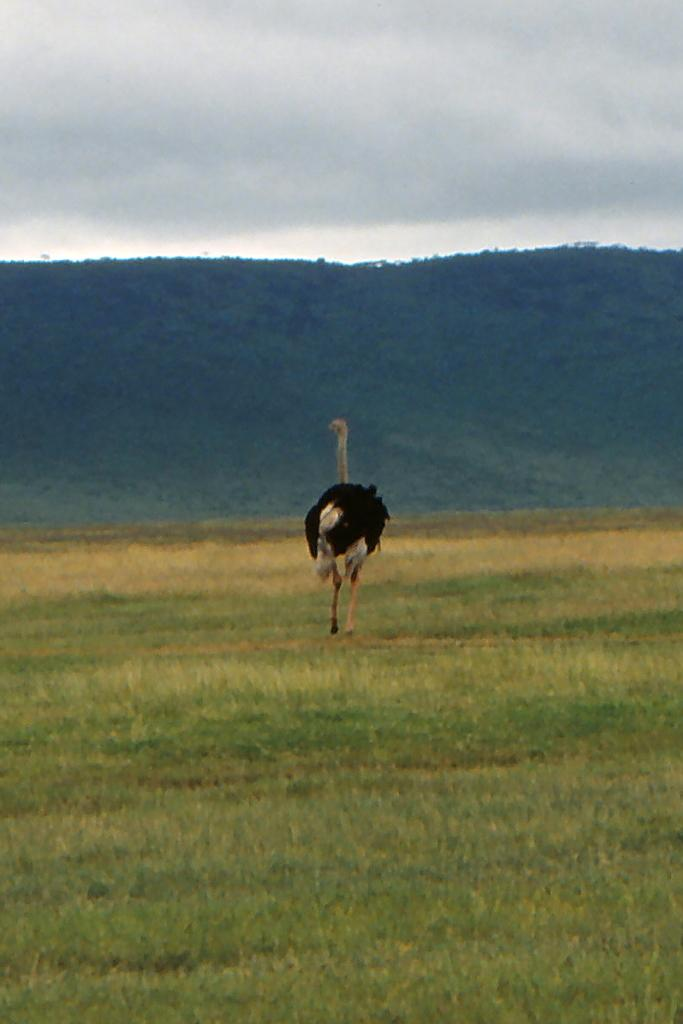What type of animal is in the image? There is an ostrich bird in the image. Where is the ostrich bird located? The ostrich bird is on the grass. What can be seen in the background of the image? There is a hill and clouds visible in the background of the image. What type of wood is the ostrich bird using to build its nest in the image? There is no wood or nest visible in the image; it only features an ostrich bird on the grass. 